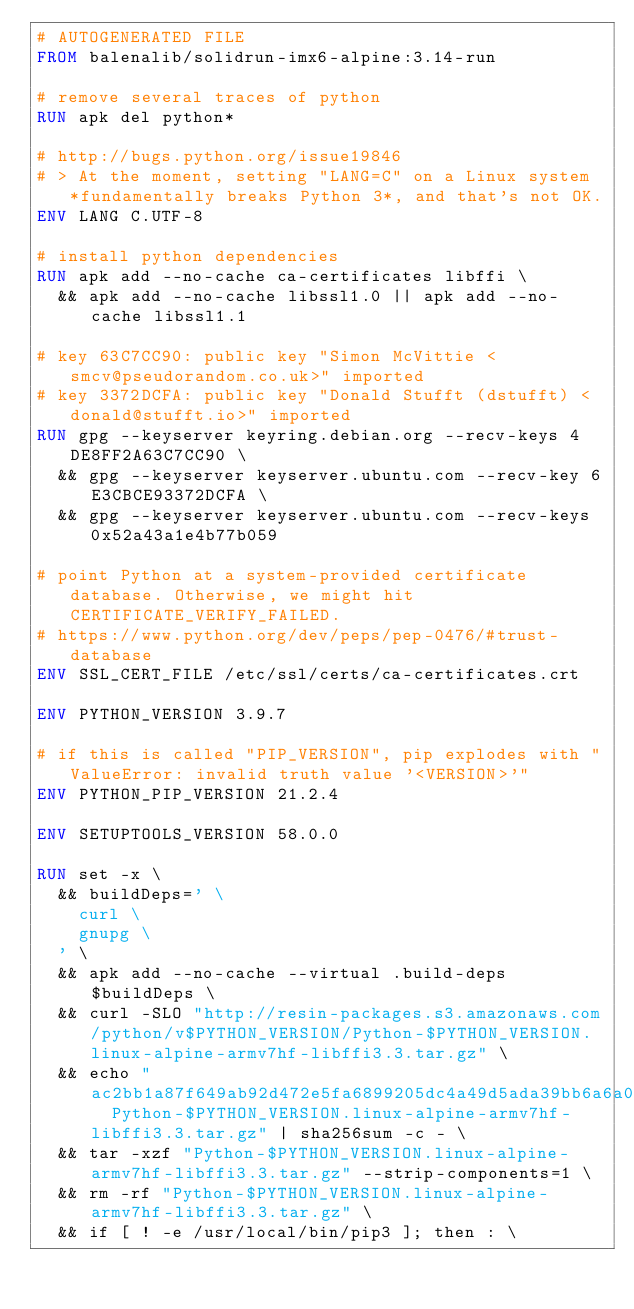Convert code to text. <code><loc_0><loc_0><loc_500><loc_500><_Dockerfile_># AUTOGENERATED FILE
FROM balenalib/solidrun-imx6-alpine:3.14-run

# remove several traces of python
RUN apk del python*

# http://bugs.python.org/issue19846
# > At the moment, setting "LANG=C" on a Linux system *fundamentally breaks Python 3*, and that's not OK.
ENV LANG C.UTF-8

# install python dependencies
RUN apk add --no-cache ca-certificates libffi \
	&& apk add --no-cache libssl1.0 || apk add --no-cache libssl1.1

# key 63C7CC90: public key "Simon McVittie <smcv@pseudorandom.co.uk>" imported
# key 3372DCFA: public key "Donald Stufft (dstufft) <donald@stufft.io>" imported
RUN gpg --keyserver keyring.debian.org --recv-keys 4DE8FF2A63C7CC90 \
	&& gpg --keyserver keyserver.ubuntu.com --recv-key 6E3CBCE93372DCFA \
	&& gpg --keyserver keyserver.ubuntu.com --recv-keys 0x52a43a1e4b77b059

# point Python at a system-provided certificate database. Otherwise, we might hit CERTIFICATE_VERIFY_FAILED.
# https://www.python.org/dev/peps/pep-0476/#trust-database
ENV SSL_CERT_FILE /etc/ssl/certs/ca-certificates.crt

ENV PYTHON_VERSION 3.9.7

# if this is called "PIP_VERSION", pip explodes with "ValueError: invalid truth value '<VERSION>'"
ENV PYTHON_PIP_VERSION 21.2.4

ENV SETUPTOOLS_VERSION 58.0.0

RUN set -x \
	&& buildDeps=' \
		curl \
		gnupg \
	' \
	&& apk add --no-cache --virtual .build-deps $buildDeps \
	&& curl -SLO "http://resin-packages.s3.amazonaws.com/python/v$PYTHON_VERSION/Python-$PYTHON_VERSION.linux-alpine-armv7hf-libffi3.3.tar.gz" \
	&& echo "ac2bb1a87f649ab92d472e5fa6899205dc4a49d5ada39bb6a6a0702c1b8b1cfa  Python-$PYTHON_VERSION.linux-alpine-armv7hf-libffi3.3.tar.gz" | sha256sum -c - \
	&& tar -xzf "Python-$PYTHON_VERSION.linux-alpine-armv7hf-libffi3.3.tar.gz" --strip-components=1 \
	&& rm -rf "Python-$PYTHON_VERSION.linux-alpine-armv7hf-libffi3.3.tar.gz" \
	&& if [ ! -e /usr/local/bin/pip3 ]; then : \</code> 